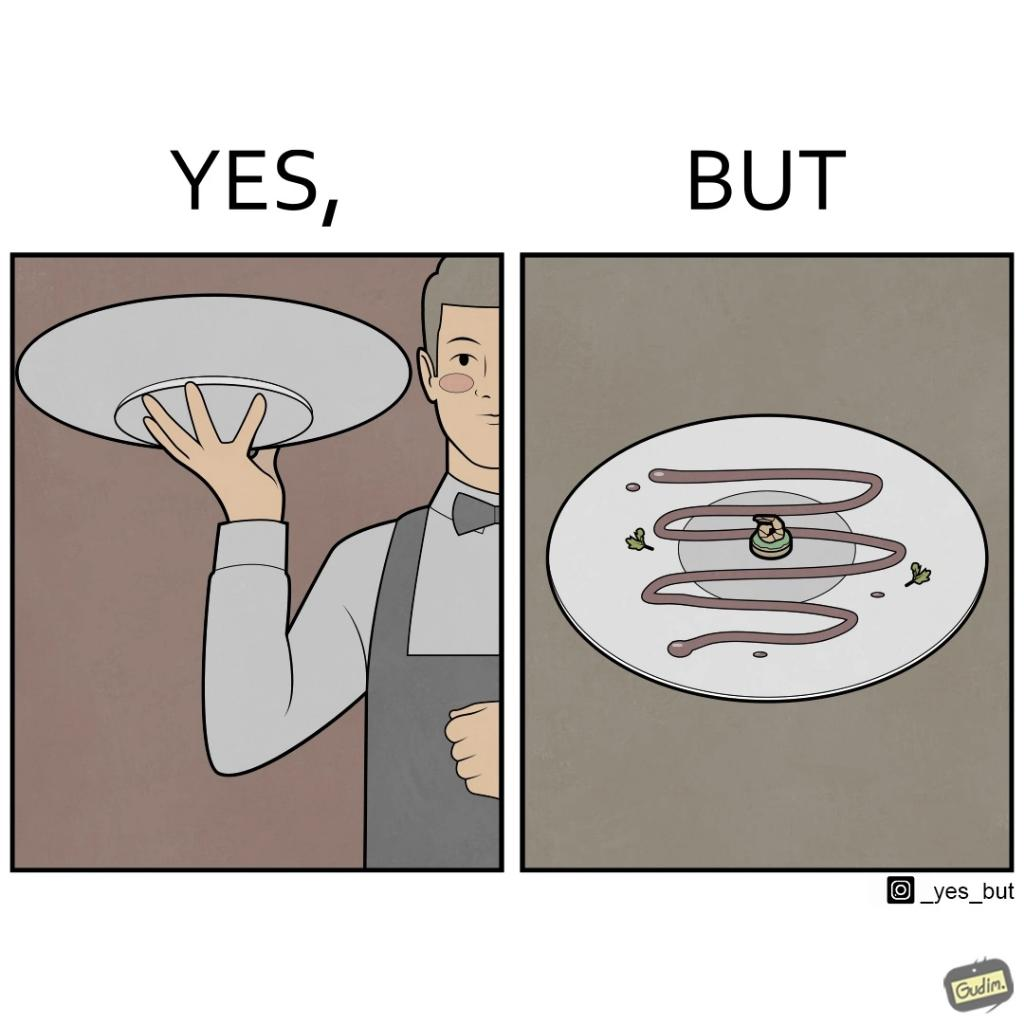Describe what you see in the left and right parts of this image. In the left part of the image: a waiter bringing some dish with some stylish posture to the table In the right part of the image: a dish with only sauce or some cream with a very small piece to eat 